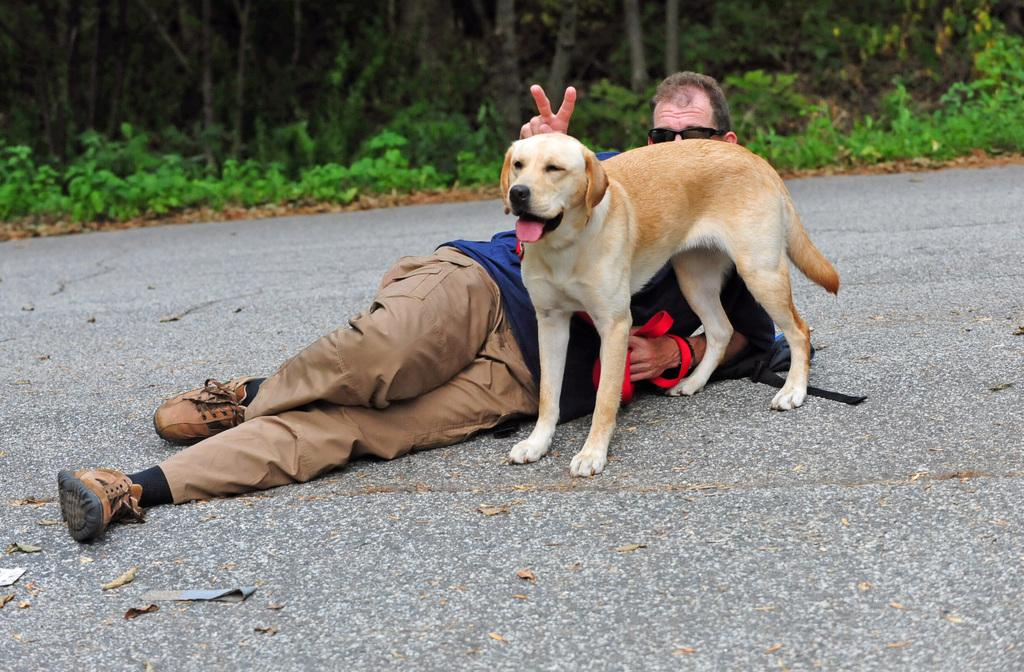What is the man in the image doing? The man is lying on the road in the image. What type of animal is present in the image? There is a dog in the image. What can be seen in the background of the image? Trees and plants are visible in the background. What type of clothing is the man wearing on his upper body? The man is wearing a T-shirt. What type of clothing is the man wearing on his lower body? The man is wearing trousers. What type of footwear is the man wearing? The man is wearing shoes. What type of protective gear is the man wearing? The man is wearing goggles. What type of cough does the man have in the image? There is no indication of a cough in the image. 